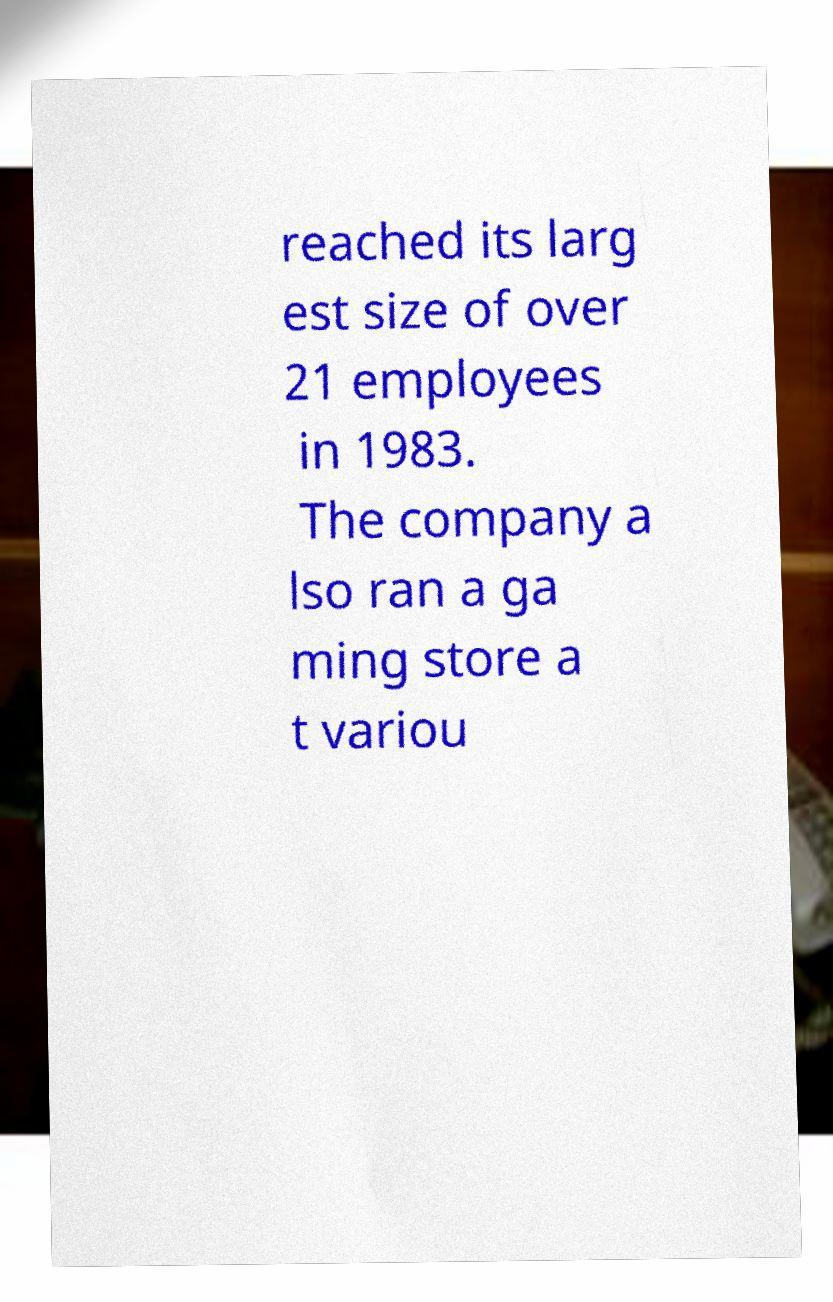Can you read and provide the text displayed in the image?This photo seems to have some interesting text. Can you extract and type it out for me? reached its larg est size of over 21 employees in 1983. The company a lso ran a ga ming store a t variou 